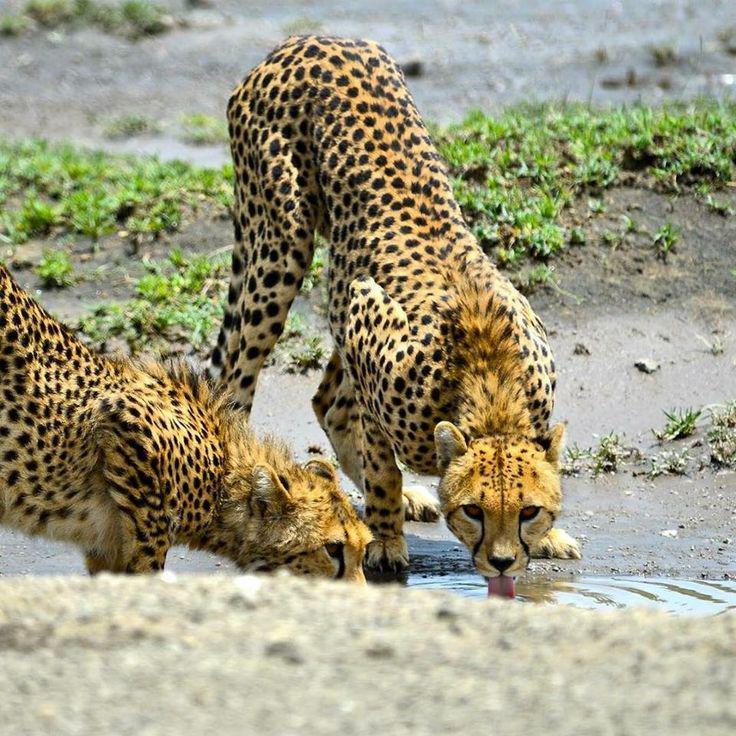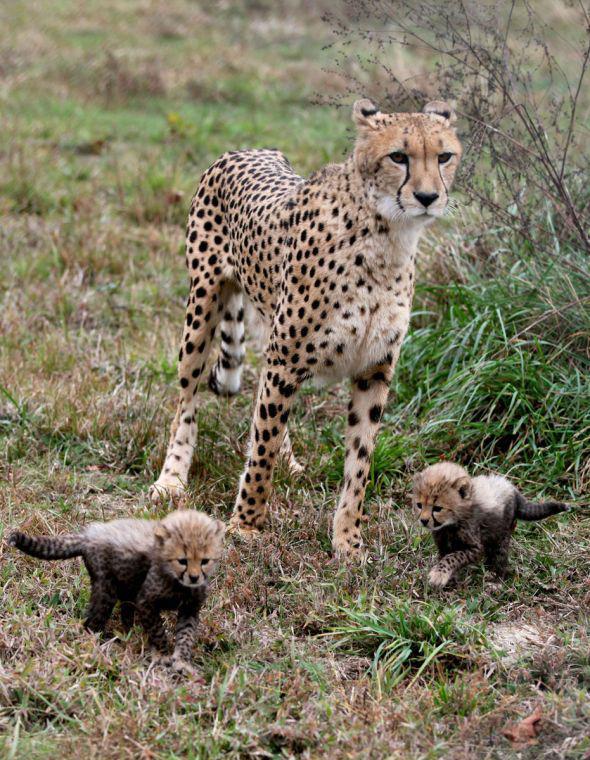The first image is the image on the left, the second image is the image on the right. Examine the images to the left and right. Is the description "there are more than 4 cheetahs in the image pair" accurate? Answer yes or no. Yes. The first image is the image on the left, the second image is the image on the right. Examine the images to the left and right. Is the description "In one image there is an adult cheetah standing over two younger cheetahs." accurate? Answer yes or no. Yes. 